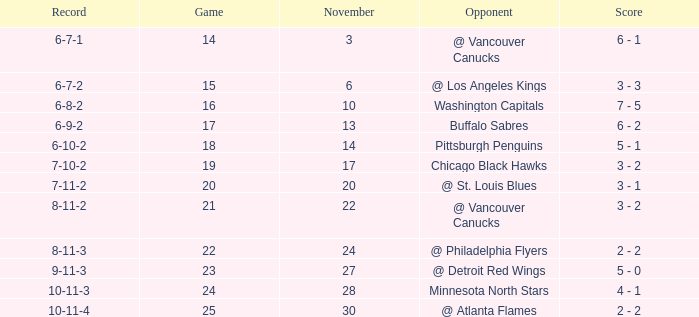Who is the opponent on november 24? @ Philadelphia Flyers. 